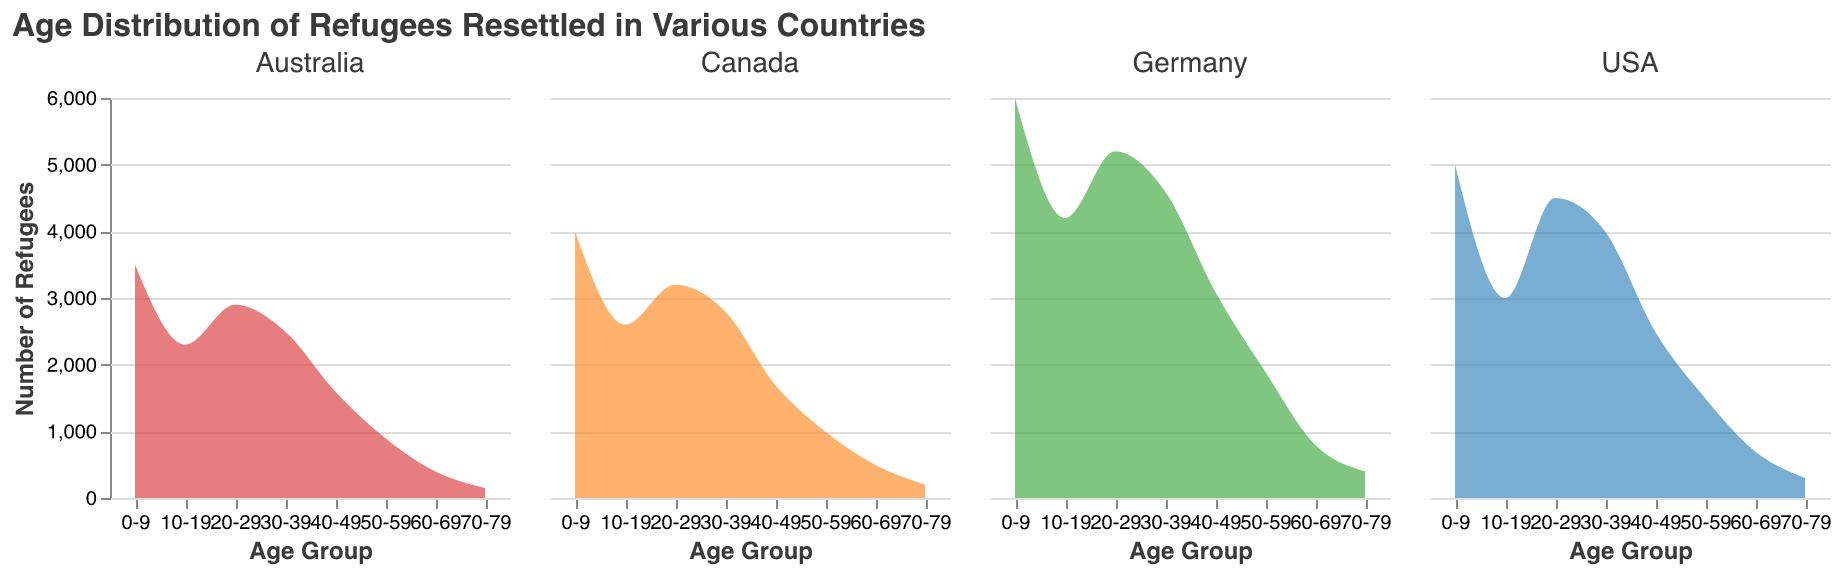What's the title of the plot? The title of the plot is specified at the top and it can easily be identified by looking at the rendered figure.
Answer: Age Distribution of Refugees Resettled in Various Countries What are the x-axis and y-axis labels? The x-axis label specifies the different age groups of refugees, and the y-axis label indicates the number of refugees in those age groups. These labels can be found directly by looking at the axes in the figure.
Answer: Age Group, Number of Refugees Which country has the highest number of resettled refugees in the age group 0-9? By looking at the peaks in the density plots for the age group 0-9, it is apparent that the highest number of refugees is for Germany as its peak is the tallest.
Answer: Germany What is the total number of resettled refugees in the USA for the age groups 20-29 and 30-39 in 2012? Sum the values for the age groups 20-29 and 30-39 in the USA in 2012: 4500 (20-29) + 4000 (30-39).
Answer: 8500 Between Canada and Australia, which country has more refugees resettled in the 50-59 age group? Comparing the density plots for the 50-59 age group between Canada and Australia, Canada has a peak at 1000 refugees, whereas Australia has a peak at 900. Thus, Canada has more.
Answer: Canada How does the age distribution in Germany compare to that in the USA? Germany has a higher number of younger refugees (age groups 0-9 and 10-19) compared to the USA. Conversely, the USA has more refugees in the middle age groups (20-49) relative to Germany. By visually analyzing the shapes and peaks of the density plots, this comparison can be made.
Answer: Germany has more younger refugees; USA has more middle-aged refugees Which country shows the smallest number of refugees in the age group 70-79, and how many are there? By examining the lowest points in the density plots for the age group 70-79, Australia can be seen to have the smallest number, which is 150 refugees.
Answer: Australia, 150 What trend can be observed in the number of refugees resettled in the 60-69 age group across all countries? By observing the density plot for the 60-69 age group, it can be noted that all four countries have comparatively lower counts in this age group. This trend indicates a general decrease.
Answer: General decrease across all countries Which age group has the largest number of refugees resettled in Canada in 2015? The highest peak in the density plot for Canada in 2015 corresponds to the age group 0-9, indicating that this age group has the largest number of resettled refugees.
Answer: 0-9 